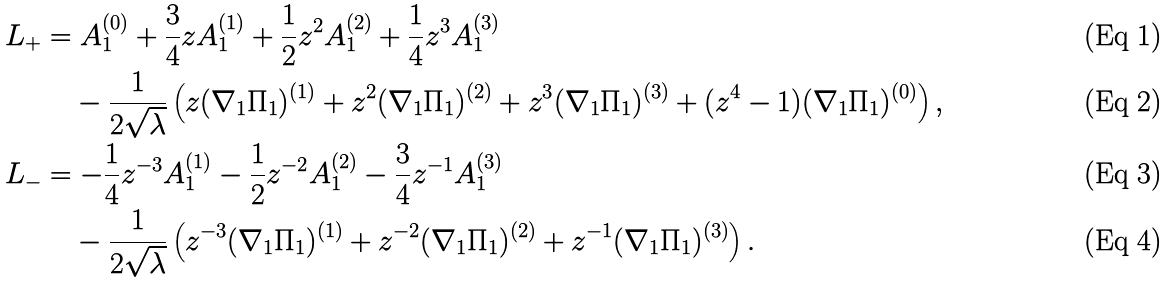<formula> <loc_0><loc_0><loc_500><loc_500>L _ { + } & = A ^ { ( 0 ) } _ { 1 } + \frac { 3 } { 4 } z A ^ { ( 1 ) } _ { 1 } + \frac { 1 } { 2 } z ^ { 2 } A ^ { ( 2 ) } _ { 1 } + \frac { 1 } { 4 } z ^ { 3 } A ^ { ( 3 ) } _ { 1 } \\ & \quad - \frac { 1 } { 2 \sqrt { \lambda } } \left ( z ( \nabla _ { 1 } \Pi _ { 1 } ) ^ { ( 1 ) } + z ^ { 2 } ( \nabla _ { 1 } \Pi _ { 1 } ) ^ { ( 2 ) } + z ^ { 3 } ( \nabla _ { 1 } \Pi _ { 1 } ) ^ { ( 3 ) } + ( z ^ { 4 } - 1 ) ( \nabla _ { 1 } \Pi _ { 1 } ) ^ { ( 0 ) } \right ) , \\ L _ { - } & = - \frac { 1 } { 4 } z ^ { - 3 } A ^ { ( 1 ) } _ { 1 } - \frac { 1 } { 2 } z ^ { - 2 } A ^ { ( 2 ) } _ { 1 } - \frac { 3 } { 4 } z ^ { - 1 } A ^ { ( 3 ) } _ { 1 } \\ & \quad - \frac { 1 } { 2 \sqrt { \lambda } } \left ( z ^ { - 3 } ( \nabla _ { 1 } \Pi _ { 1 } ) ^ { ( 1 ) } + z ^ { - 2 } ( \nabla _ { 1 } \Pi _ { 1 } ) ^ { ( 2 ) } + z ^ { - 1 } ( \nabla _ { 1 } \Pi _ { 1 } ) ^ { ( 3 ) } \right ) .</formula> 